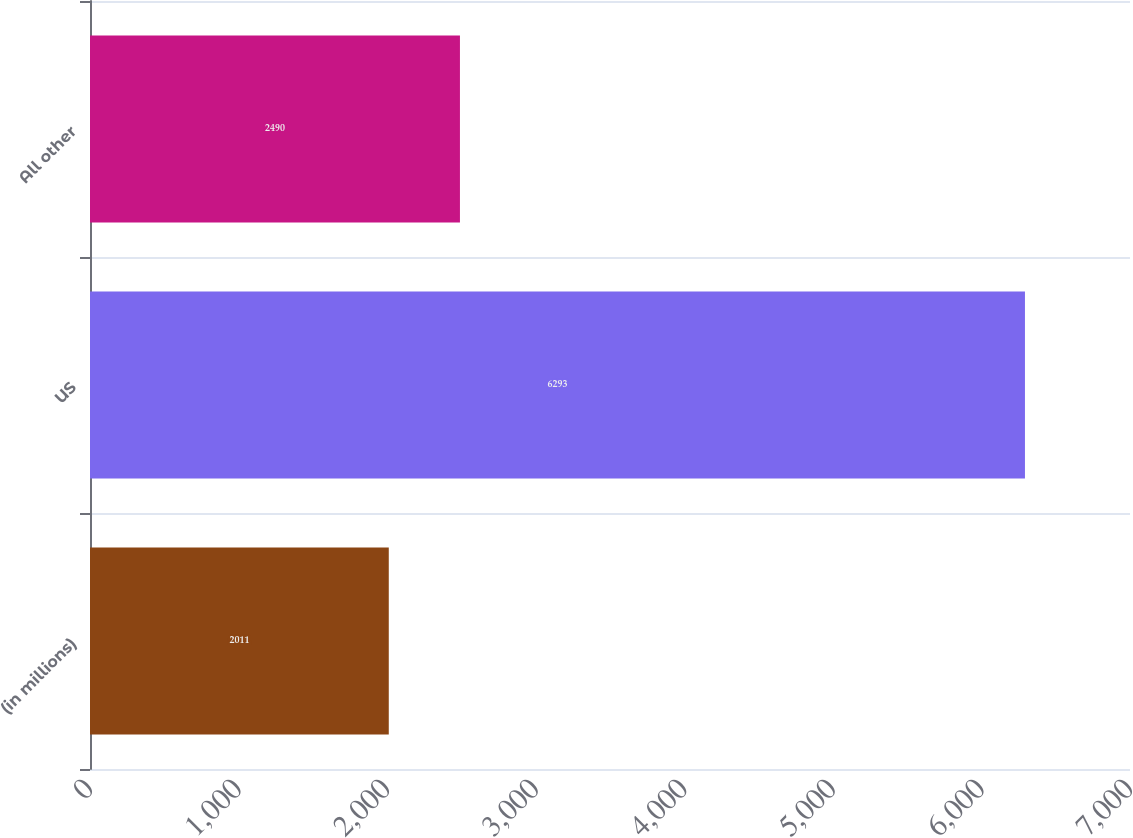Convert chart. <chart><loc_0><loc_0><loc_500><loc_500><bar_chart><fcel>(in millions)<fcel>US<fcel>All other<nl><fcel>2011<fcel>6293<fcel>2490<nl></chart> 